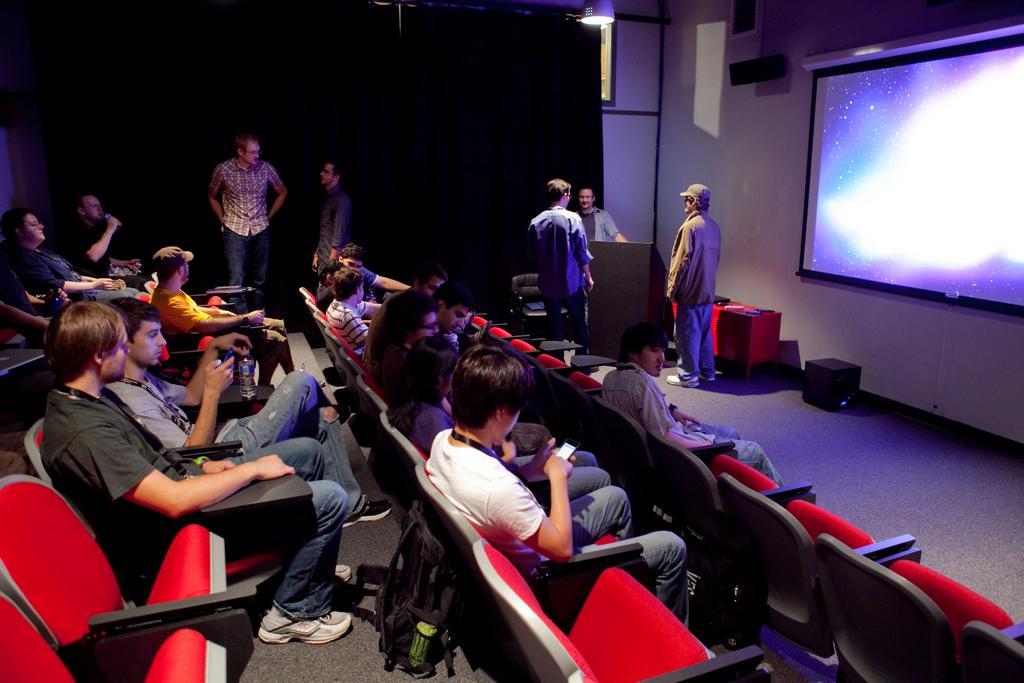Could you give a brief overview of what you see in this image? There are group of people sitting on the chairs. This is the screen with the display. I think this is the speaker attached to the wall. This looks like a podium, which is black in color. I can see few people standing. At the top, I can see the lamp. This is the black cloth hanging to the hanger. I can see few empty chairs. This looks like a black color object, which is placed on the floor. I can see a table covered with a red cloth and few objects are placed on it. 